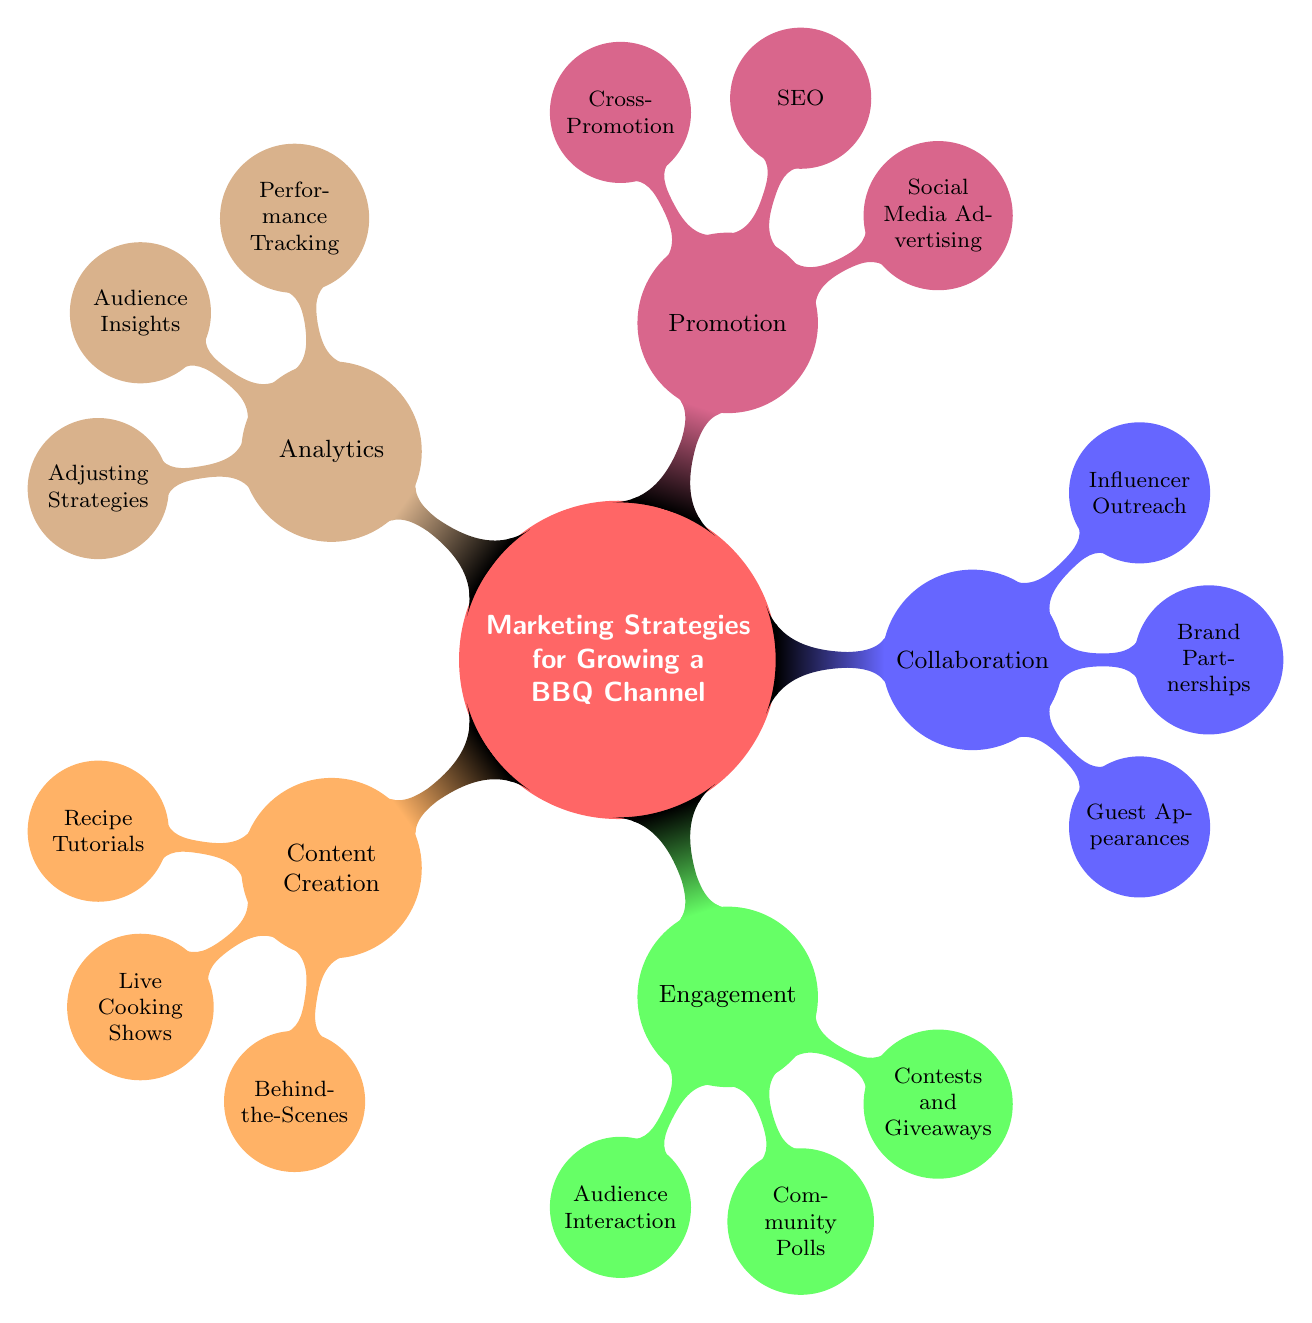What are the five main branches of the mind map? The five main branches are Content Creation, Engagement, Collaboration, Promotion, and Analytics. These are the primary categories representing marketing strategies for the BBQ channel.
Answer: Content Creation, Engagement, Collaboration, Promotion, Analytics How many nodes are under Engagement? There are three nodes under the Engagement category: Audience Interaction, Community Polls, and Contests and Giveaways. Each represents a different strategy for engaging the audience.
Answer: 3 What type of content does the node "Live Cooking Shows" represent? The "Live Cooking Shows" node represents a format of content creation designed for viewer interaction through live sessions. It falls under the Content Creation branch.
Answer: Interactive live sessions Which branch includes "Brand Partnerships"? The "Brand Partnerships" node is included in the Collaboration branch. This node focuses on working with brands to enhance the channel's reach and visibility.
Answer: Collaboration How does "SEO" relate to "Social Media Advertising"? "SEO" and "Social Media Advertising" are both part of the Promotion branch. They represent different strategies for promoting the BBQ channel: SEO focuses on search engine visibility, while social media advertising targets users directly through paid ads.
Answer: Part of Promotion What is the purpose of "Audience Insights"? The purpose of "Audience Insights" is to analyze viewer demographics and preferences, helping to tailor content to the audience's interests, which is part of the Analytics branch.
Answer: Analyzing demographics How many nodes are there in total? To find the total, count all nodes across branches: Content Creation (3) + Engagement (3) + Collaboration (3) + Promotion (3) + Analytics (3) equals 15 nodes in total.
Answer: 15 What nodes fall under the "Collaboration" branch? The nodes under the Collaboration branch are Guest Appearances, Brand Partnerships, and Influencer Outreach. These represent collaborative efforts to grow the channel.
Answer: Guest Appearances, Brand Partnerships, Influencer Outreach What kind of contests are indicated by "Contests and Giveaways"? "Contests and Giveaways" refer to engaging fans with BBQ-related prizes, which falls under the Engagement branch and aims to interact with the audience.
Answer: BBQ-related prizes 